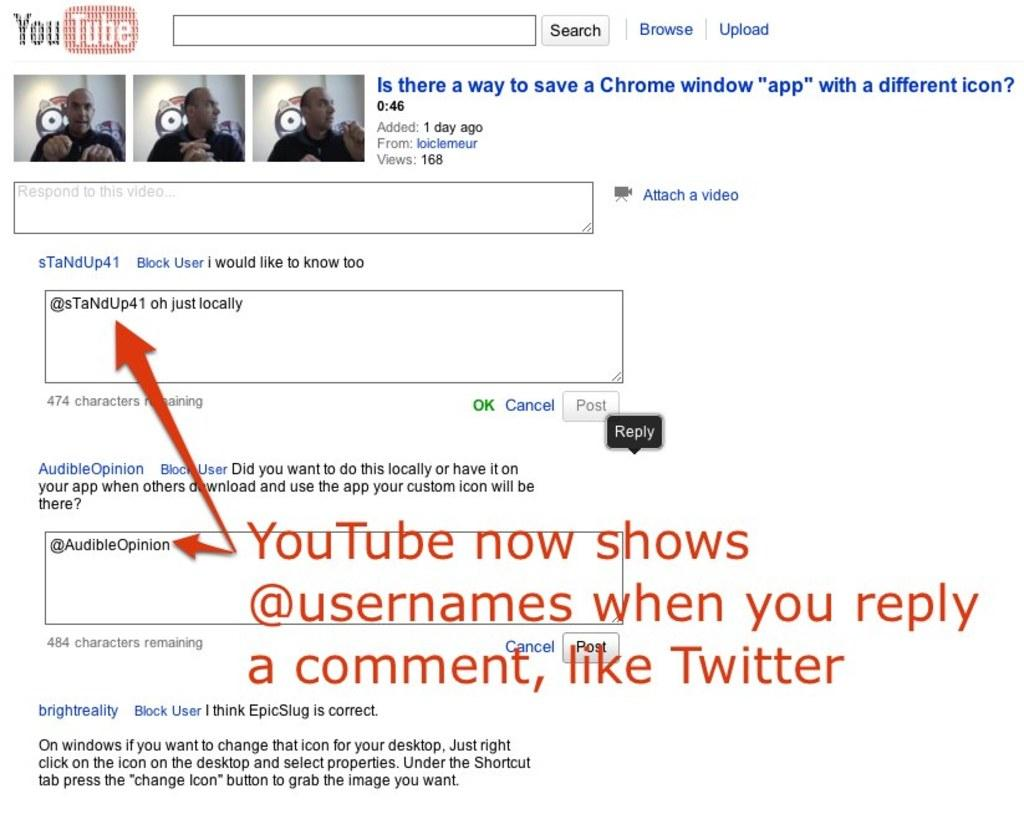What is the main subject of the image? The main subject of the image is a screenshot. What can be seen within the screenshot? There are person images in the screenshot. Is there any text present in the image? Yes, there is text written on the image. What type of jar is visible in the image? There is no jar present in the image. How does the hair of the person in the image look? There is no hair visible in the image, as it only shows person images within a screenshot. 